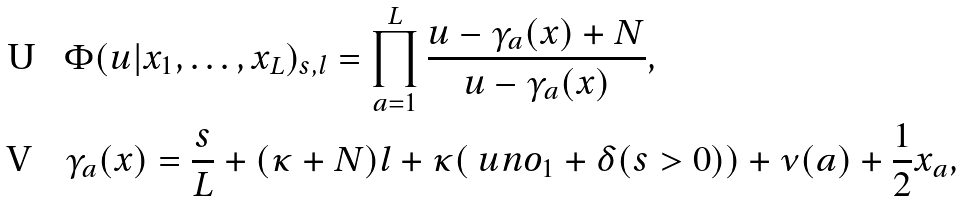Convert formula to latex. <formula><loc_0><loc_0><loc_500><loc_500>& \Phi ( u | x _ { 1 } , \dots , x _ { L } ) _ { s , l } = \prod _ { a = 1 } ^ { L } \frac { u - \gamma _ { a } ( x ) + N } { u - \gamma _ { a } ( x ) } , \\ & \gamma _ { a } ( x ) = \frac { s } { L } + ( \kappa + N ) l + \kappa ( \ u n { o _ { 1 } } + \delta ( s > 0 ) ) + \nu ( a ) + \frac { 1 } { 2 } x _ { a } ,</formula> 